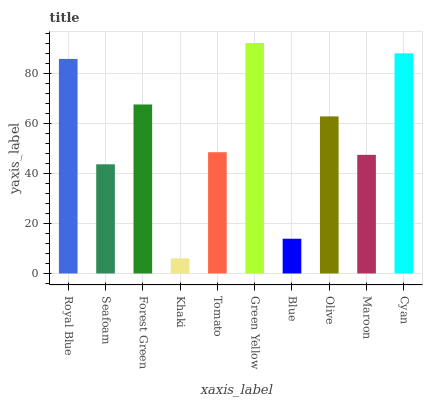Is Seafoam the minimum?
Answer yes or no. No. Is Seafoam the maximum?
Answer yes or no. No. Is Royal Blue greater than Seafoam?
Answer yes or no. Yes. Is Seafoam less than Royal Blue?
Answer yes or no. Yes. Is Seafoam greater than Royal Blue?
Answer yes or no. No. Is Royal Blue less than Seafoam?
Answer yes or no. No. Is Olive the high median?
Answer yes or no. Yes. Is Tomato the low median?
Answer yes or no. Yes. Is Royal Blue the high median?
Answer yes or no. No. Is Seafoam the low median?
Answer yes or no. No. 